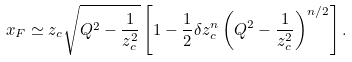Convert formula to latex. <formula><loc_0><loc_0><loc_500><loc_500>x _ { F } \simeq z _ { c } \sqrt { Q ^ { 2 } - \frac { 1 } { z _ { c } ^ { 2 } } } \left [ 1 - \frac { 1 } { 2 } \delta z _ { c } ^ { n } \left ( Q ^ { 2 } - \frac { 1 } { z _ { c } ^ { 2 } } \right ) ^ { n / 2 } \right ] .</formula> 